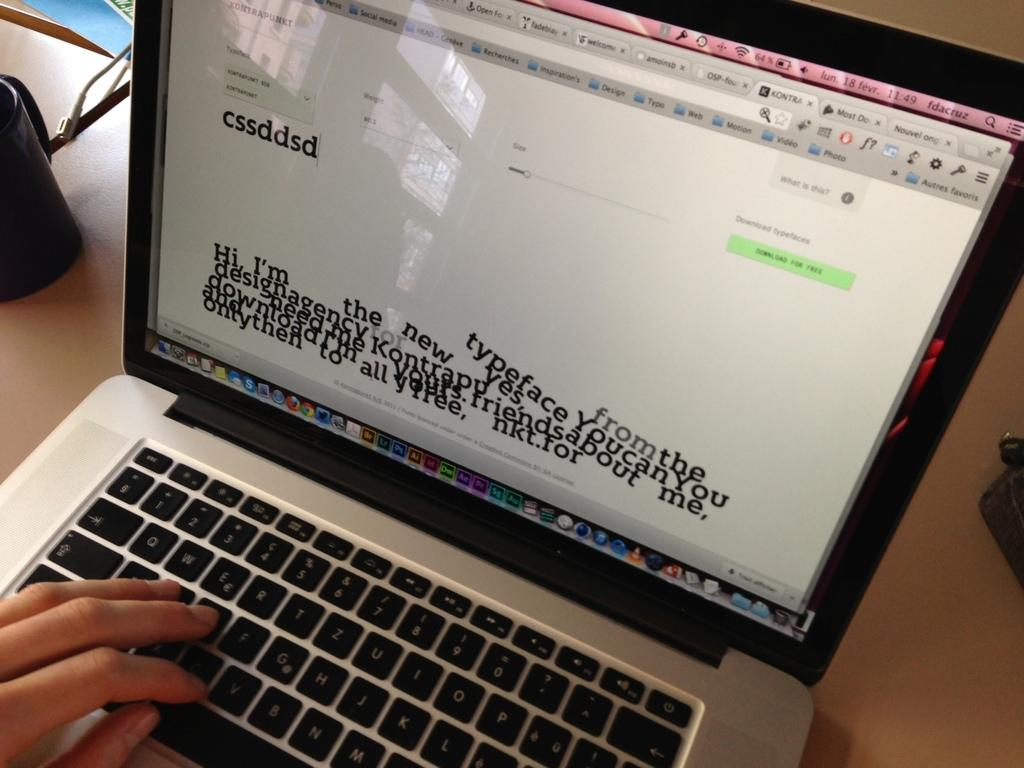<image>
Write a terse but informative summary of the picture. a laptop is showing a screen with a lot of texts from a design agency. 